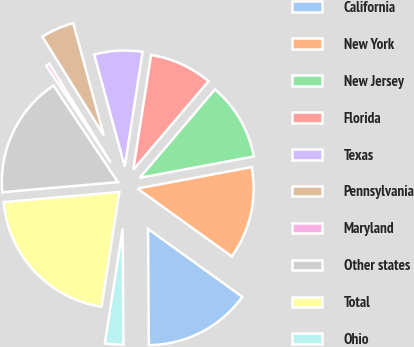Convert chart to OTSL. <chart><loc_0><loc_0><loc_500><loc_500><pie_chart><fcel>California<fcel>New York<fcel>New Jersey<fcel>Florida<fcel>Texas<fcel>Pennsylvania<fcel>Maryland<fcel>Other states<fcel>Total<fcel>Ohio<nl><fcel>14.96%<fcel>12.89%<fcel>10.83%<fcel>8.76%<fcel>6.69%<fcel>4.63%<fcel>0.5%<fcel>17.03%<fcel>21.16%<fcel>2.56%<nl></chart> 